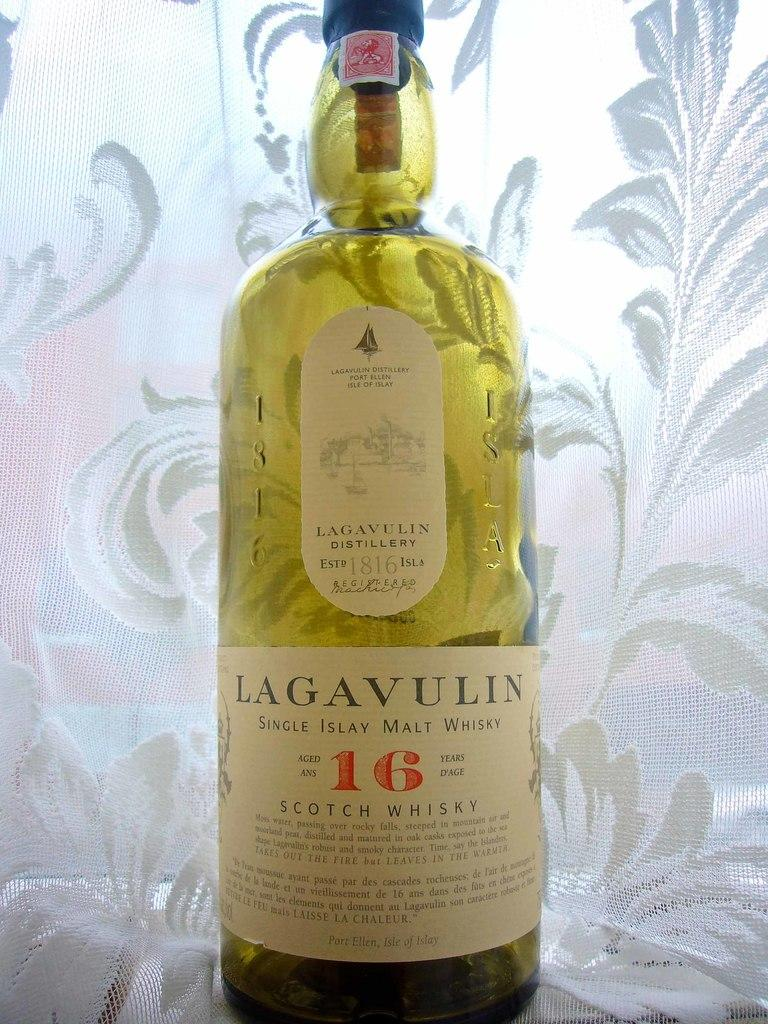What is the main object in the image? There is a wine bottle in the image. What appliance is being offered by the wine bottle in the image? There is no appliance being offered by the wine bottle in the image, as it is an inanimate object. 